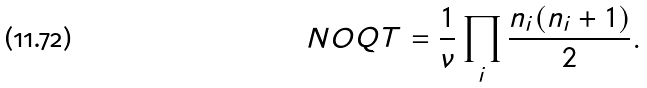<formula> <loc_0><loc_0><loc_500><loc_500>N O Q T = \frac { 1 } { \nu } \prod _ { i } \frac { n _ { i } ( n _ { i } + 1 ) } { 2 } .</formula> 